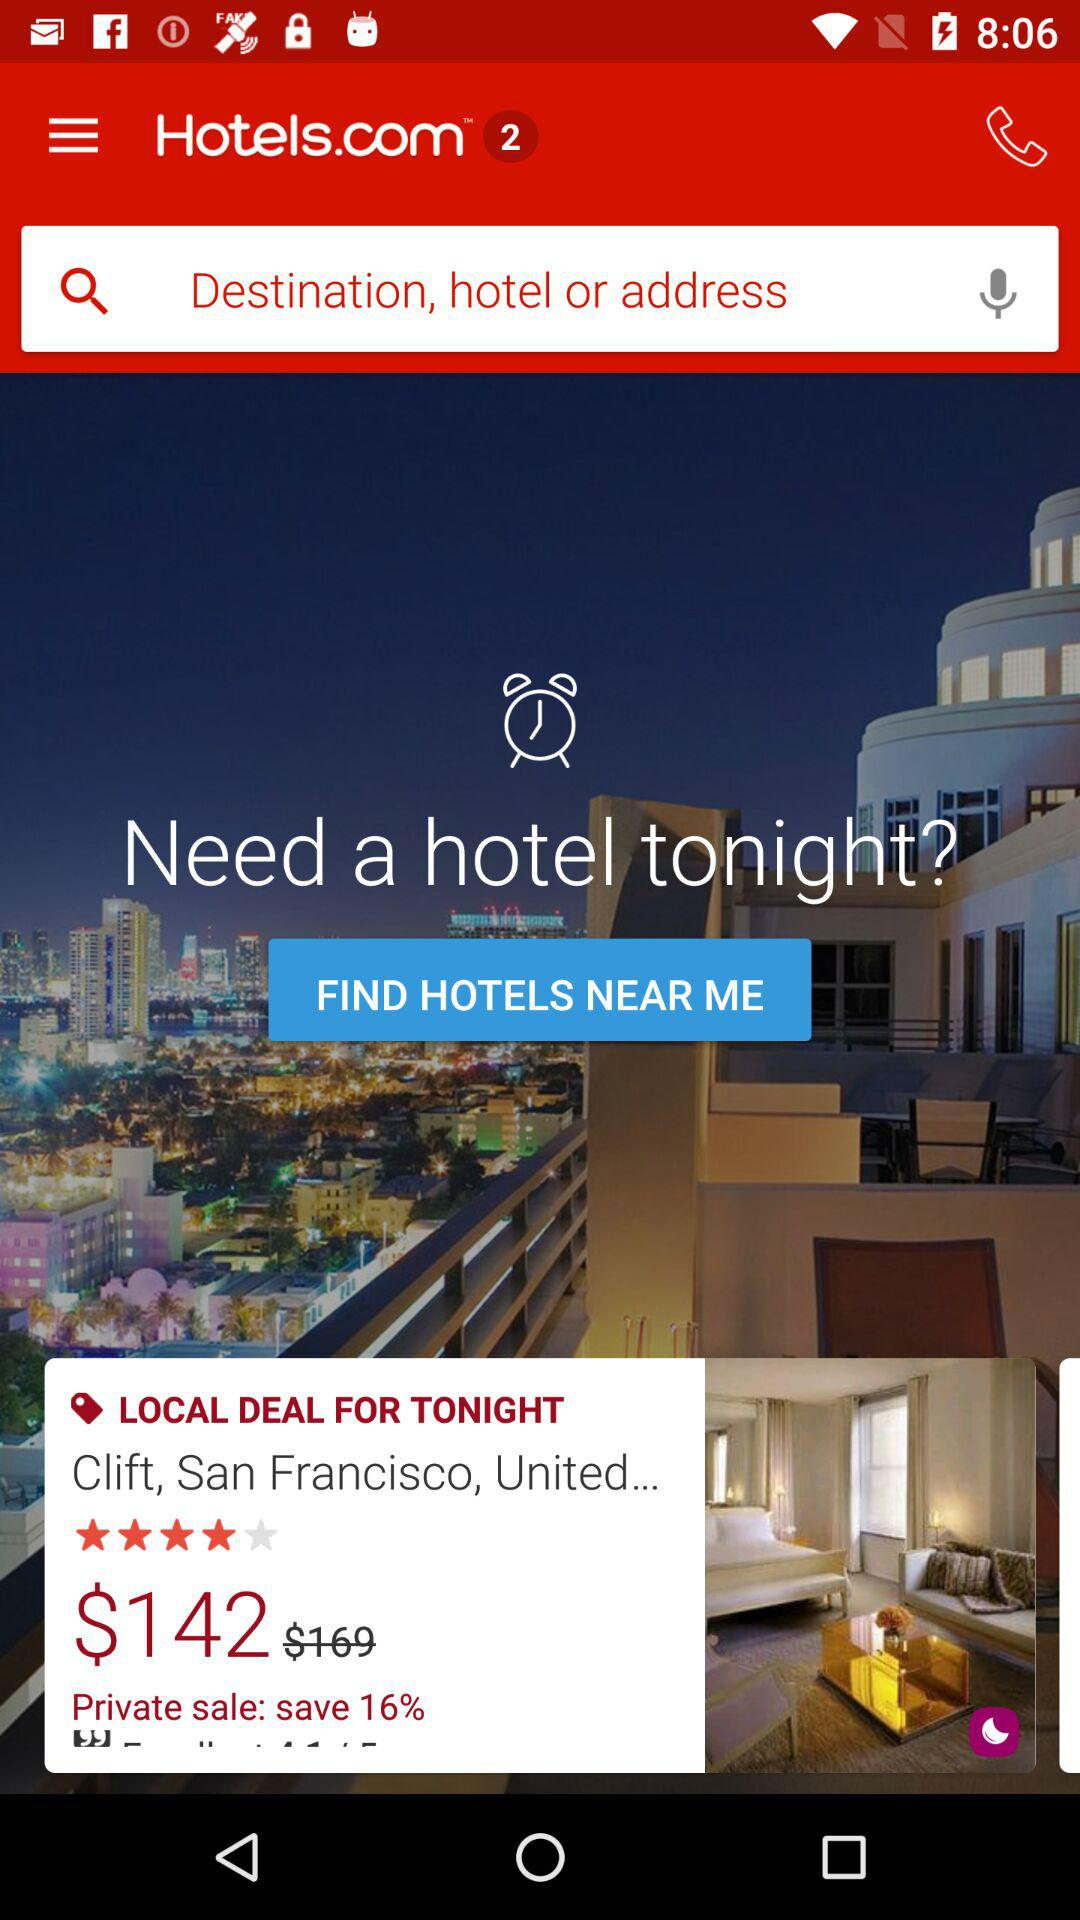What is the address?
Answer the question using a single word or phrase. The address is "Clift, San Francisco, United..." 